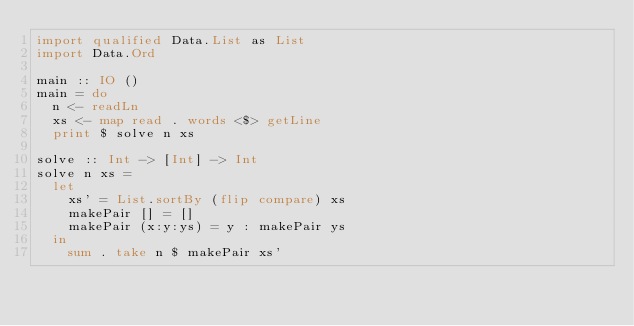Convert code to text. <code><loc_0><loc_0><loc_500><loc_500><_Haskell_>import qualified Data.List as List
import Data.Ord

main :: IO ()
main = do
  n <- readLn
  xs <- map read . words <$> getLine
  print $ solve n xs

solve :: Int -> [Int] -> Int
solve n xs =
  let
    xs' = List.sortBy (flip compare) xs
    makePair [] = []
    makePair (x:y:ys) = y : makePair ys
  in
    sum . take n $ makePair xs'</code> 